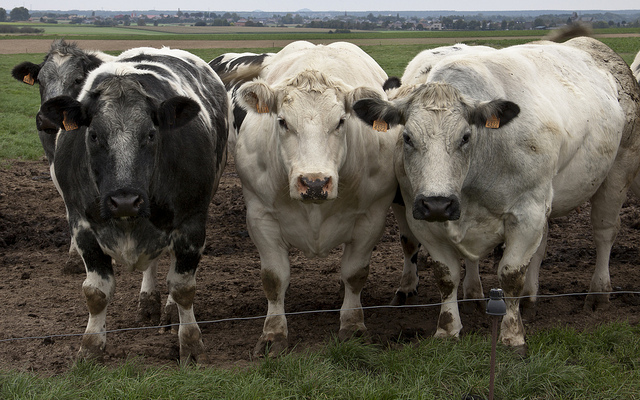What might the environment tell us about the habits or conditions of these cows? The muddy foreground suggests recent rainfall or a generally wet climate in this area, which might indicate that the cows frequently deal with muddy conditions. Such environments can affect the health of the cows, particularly their hooves. The openness of the field, without visible shelter, also suggests that these cows are accustomed to being outdoors most of the time, which could be characteristic of free-range farming practices. 